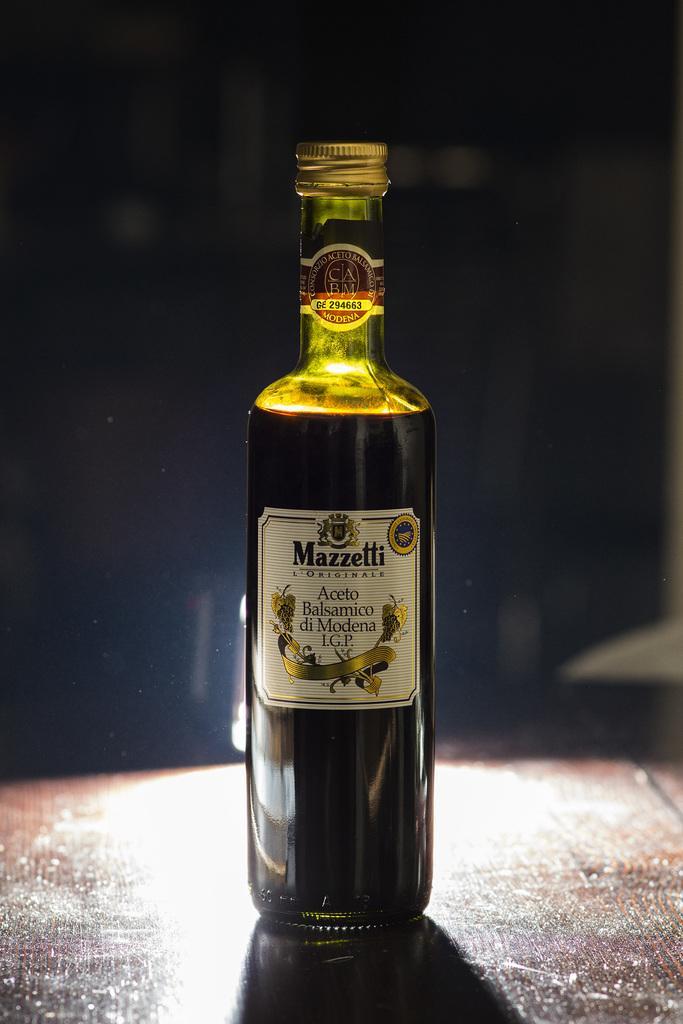Please provide a concise description of this image. This image consists of a bottle. It has some liquid in it. It is placed on a table. 